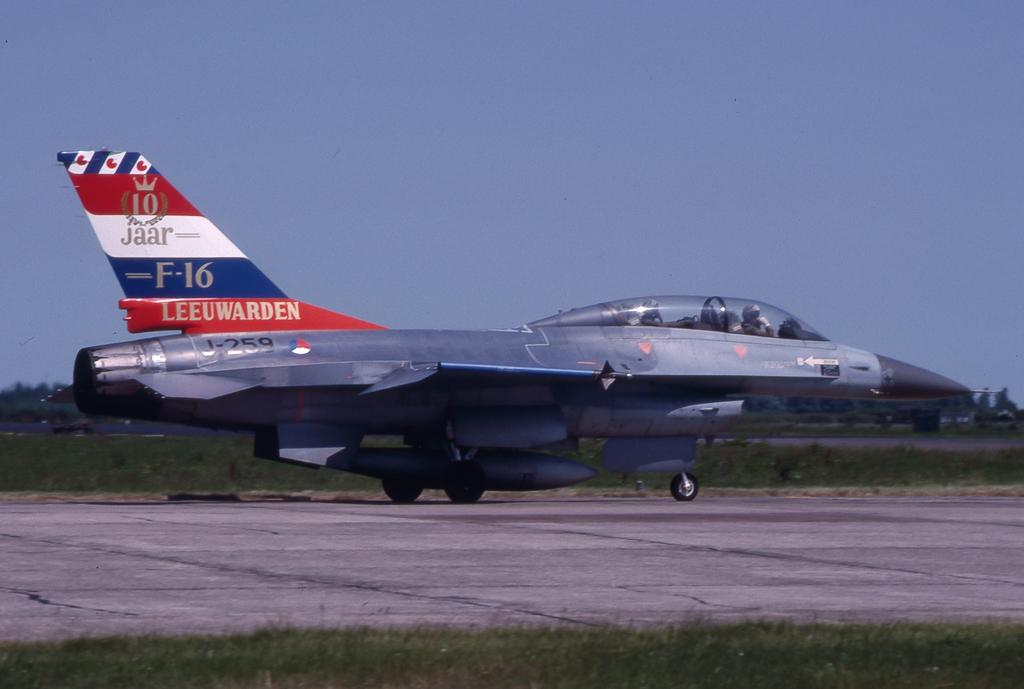<image>
Offer a succinct explanation of the picture presented. An airplaine from the airline Leeuwarde, it is an F-16. 